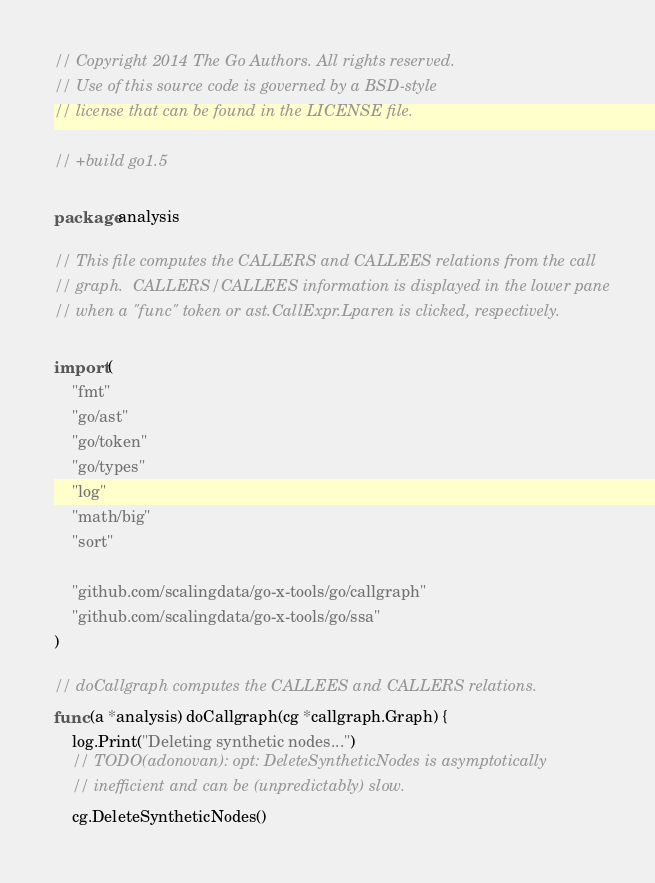<code> <loc_0><loc_0><loc_500><loc_500><_Go_>// Copyright 2014 The Go Authors. All rights reserved.
// Use of this source code is governed by a BSD-style
// license that can be found in the LICENSE file.

// +build go1.5

package analysis

// This file computes the CALLERS and CALLEES relations from the call
// graph.  CALLERS/CALLEES information is displayed in the lower pane
// when a "func" token or ast.CallExpr.Lparen is clicked, respectively.

import (
	"fmt"
	"go/ast"
	"go/token"
	"go/types"
	"log"
	"math/big"
	"sort"

	"github.com/scalingdata/go-x-tools/go/callgraph"
	"github.com/scalingdata/go-x-tools/go/ssa"
)

// doCallgraph computes the CALLEES and CALLERS relations.
func (a *analysis) doCallgraph(cg *callgraph.Graph) {
	log.Print("Deleting synthetic nodes...")
	// TODO(adonovan): opt: DeleteSyntheticNodes is asymptotically
	// inefficient and can be (unpredictably) slow.
	cg.DeleteSyntheticNodes()</code> 